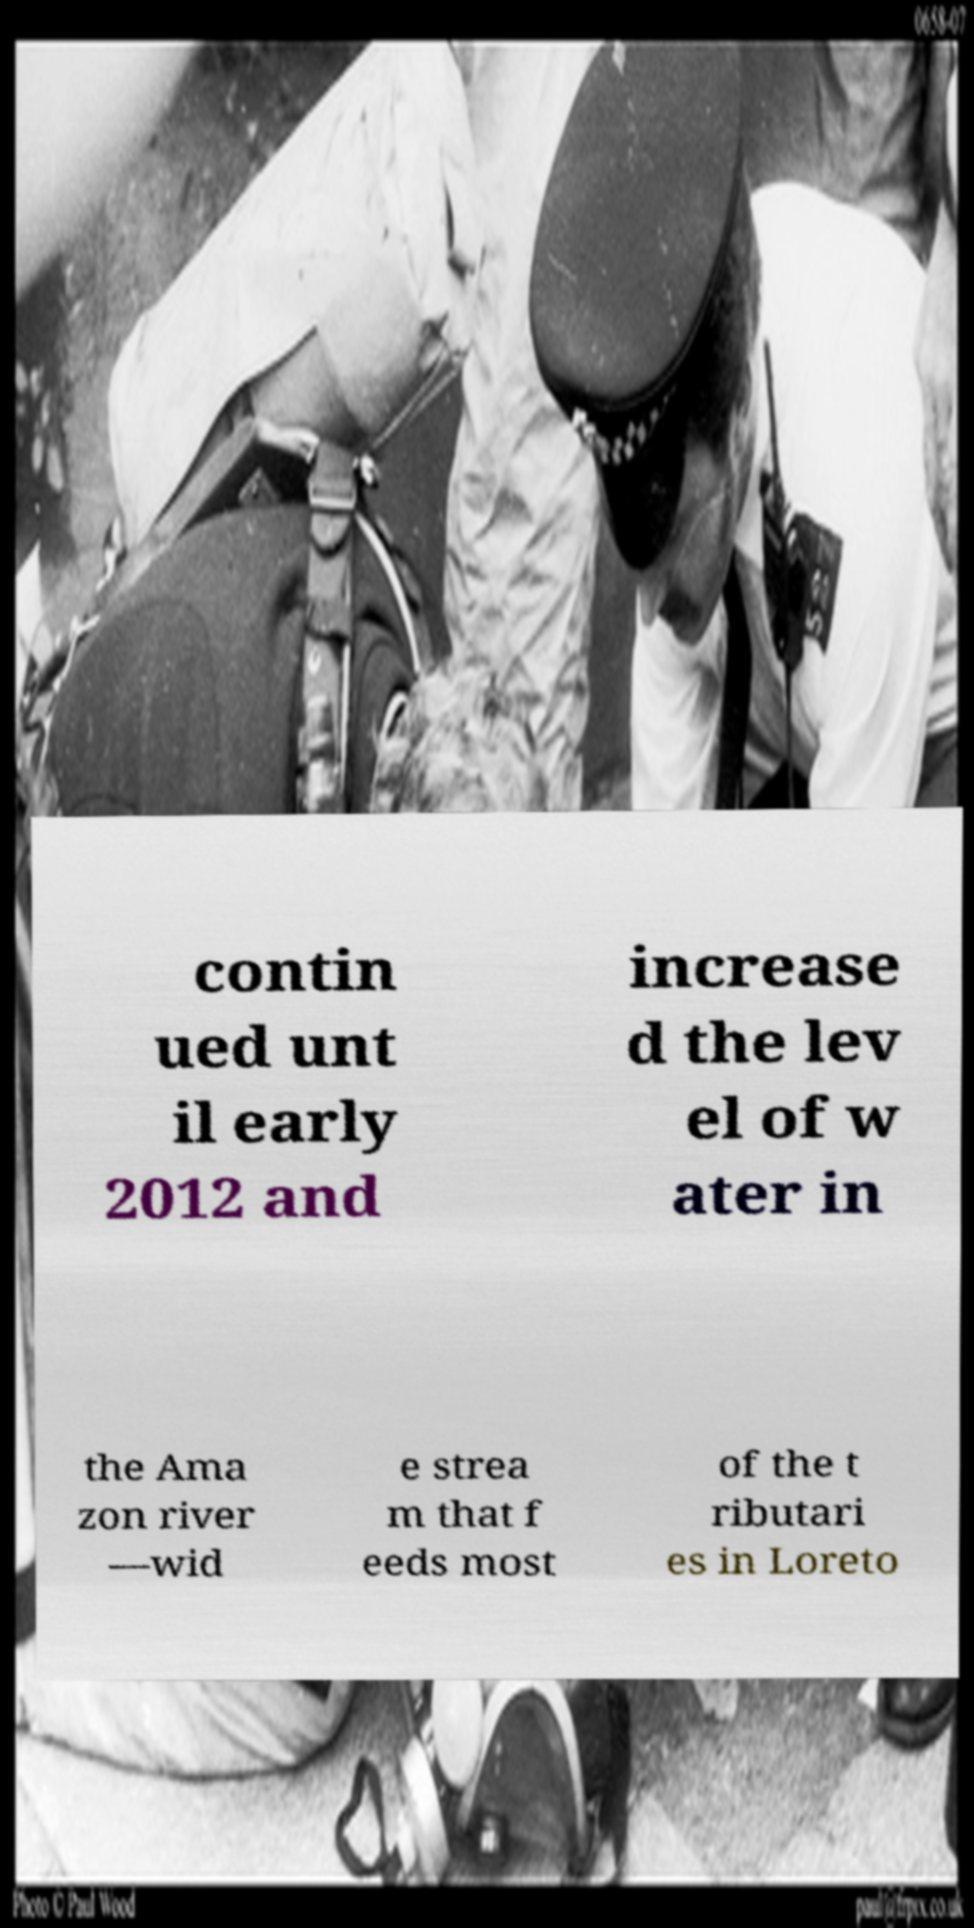Can you read and provide the text displayed in the image?This photo seems to have some interesting text. Can you extract and type it out for me? contin ued unt il early 2012 and increase d the lev el of w ater in the Ama zon river —wid e strea m that f eeds most of the t ributari es in Loreto 